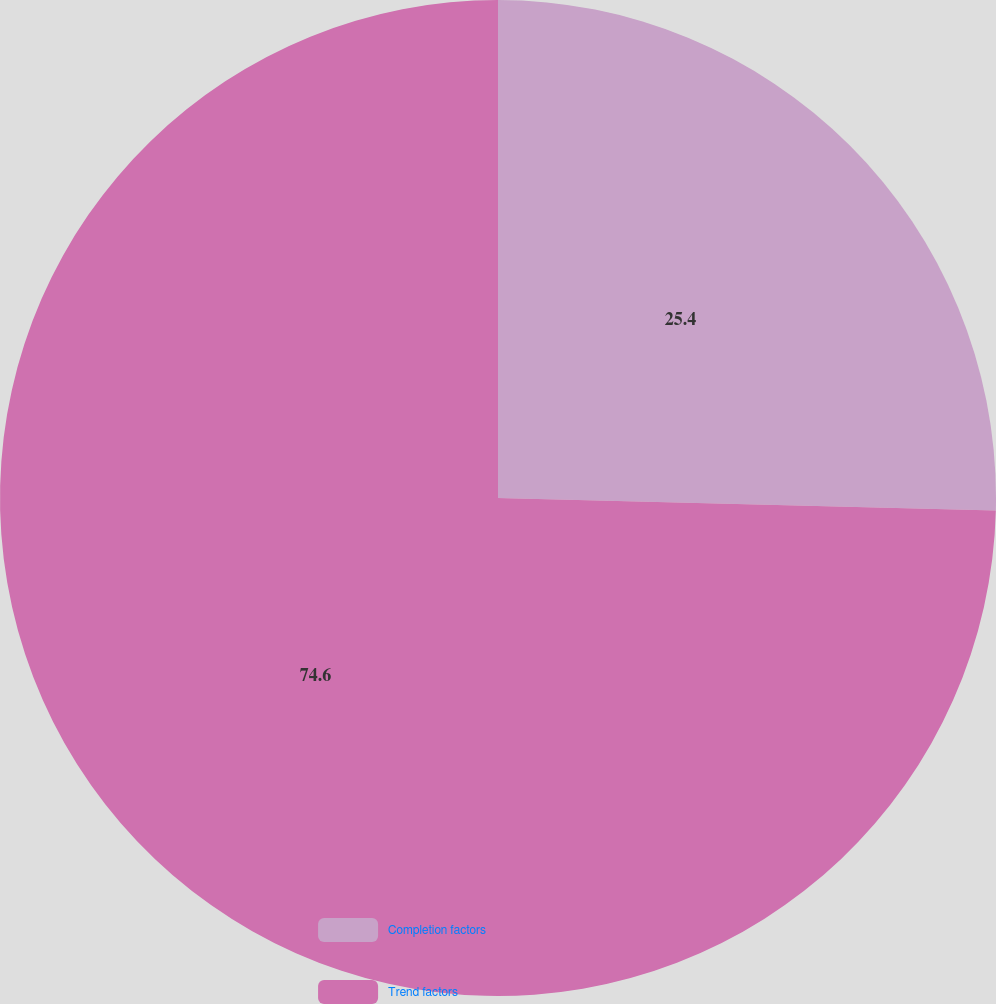Convert chart. <chart><loc_0><loc_0><loc_500><loc_500><pie_chart><fcel>Completion factors<fcel>Trend factors<nl><fcel>25.4%<fcel>74.6%<nl></chart> 